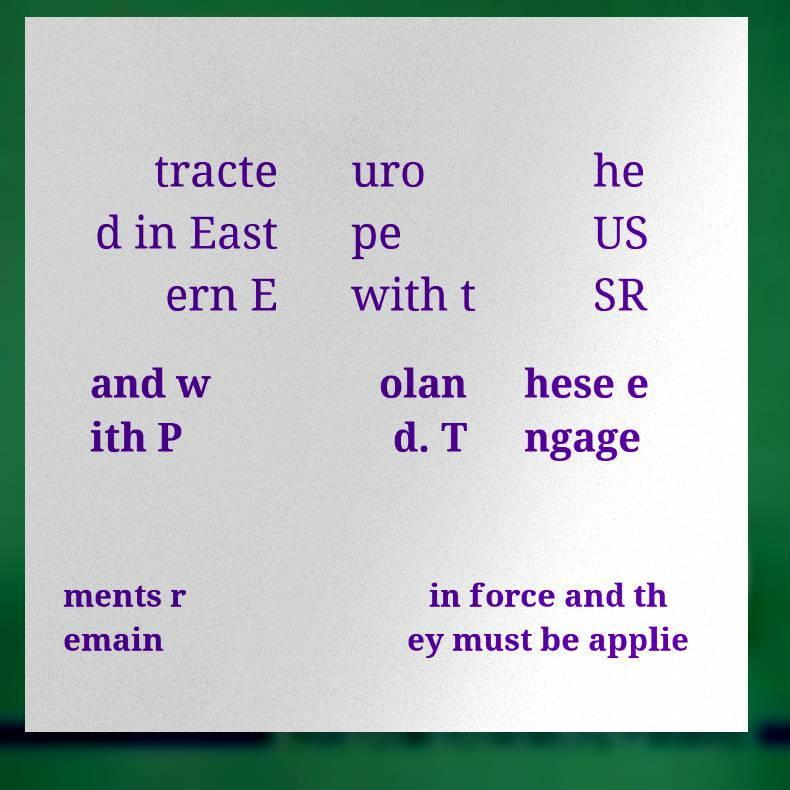There's text embedded in this image that I need extracted. Can you transcribe it verbatim? tracte d in East ern E uro pe with t he US SR and w ith P olan d. T hese e ngage ments r emain in force and th ey must be applie 